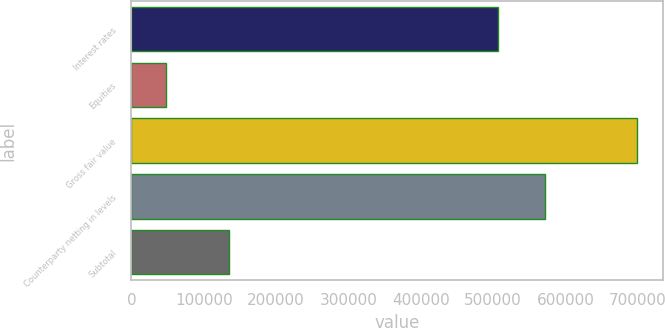Convert chart to OTSL. <chart><loc_0><loc_0><loc_500><loc_500><bar_chart><fcel>Interest rates<fcel>Equities<fcel>Gross fair value<fcel>Counterparty netting in levels<fcel>Subtotal<nl><fcel>506818<fcel>47667<fcel>699585<fcel>572010<fcel>135485<nl></chart> 